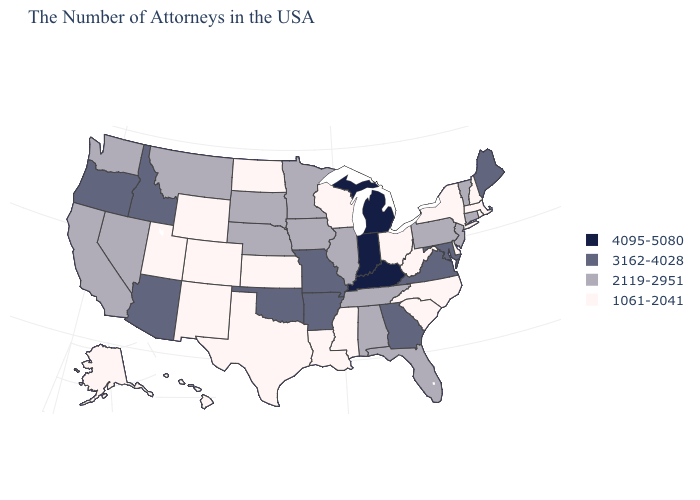Which states hav the highest value in the MidWest?
Keep it brief. Michigan, Indiana. Name the states that have a value in the range 1061-2041?
Quick response, please. Massachusetts, Rhode Island, New Hampshire, New York, Delaware, North Carolina, South Carolina, West Virginia, Ohio, Wisconsin, Mississippi, Louisiana, Kansas, Texas, North Dakota, Wyoming, Colorado, New Mexico, Utah, Alaska, Hawaii. Name the states that have a value in the range 4095-5080?
Keep it brief. Michigan, Kentucky, Indiana. What is the lowest value in the USA?
Concise answer only. 1061-2041. Name the states that have a value in the range 1061-2041?
Keep it brief. Massachusetts, Rhode Island, New Hampshire, New York, Delaware, North Carolina, South Carolina, West Virginia, Ohio, Wisconsin, Mississippi, Louisiana, Kansas, Texas, North Dakota, Wyoming, Colorado, New Mexico, Utah, Alaska, Hawaii. Name the states that have a value in the range 2119-2951?
Concise answer only. Vermont, Connecticut, New Jersey, Pennsylvania, Florida, Alabama, Tennessee, Illinois, Minnesota, Iowa, Nebraska, South Dakota, Montana, Nevada, California, Washington. Does New York have the lowest value in the Northeast?
Keep it brief. Yes. Among the states that border New York , which have the highest value?
Short answer required. Vermont, Connecticut, New Jersey, Pennsylvania. Among the states that border West Virginia , which have the lowest value?
Concise answer only. Ohio. Name the states that have a value in the range 4095-5080?
Answer briefly. Michigan, Kentucky, Indiana. Is the legend a continuous bar?
Write a very short answer. No. What is the highest value in states that border Iowa?
Be succinct. 3162-4028. Name the states that have a value in the range 3162-4028?
Quick response, please. Maine, Maryland, Virginia, Georgia, Missouri, Arkansas, Oklahoma, Arizona, Idaho, Oregon. Name the states that have a value in the range 2119-2951?
Keep it brief. Vermont, Connecticut, New Jersey, Pennsylvania, Florida, Alabama, Tennessee, Illinois, Minnesota, Iowa, Nebraska, South Dakota, Montana, Nevada, California, Washington. Name the states that have a value in the range 1061-2041?
Short answer required. Massachusetts, Rhode Island, New Hampshire, New York, Delaware, North Carolina, South Carolina, West Virginia, Ohio, Wisconsin, Mississippi, Louisiana, Kansas, Texas, North Dakota, Wyoming, Colorado, New Mexico, Utah, Alaska, Hawaii. 